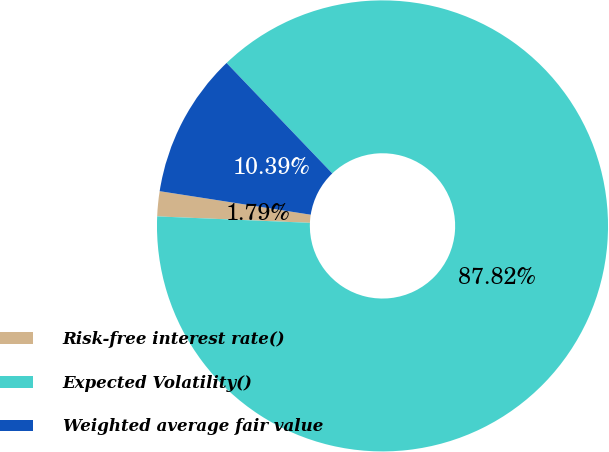Convert chart to OTSL. <chart><loc_0><loc_0><loc_500><loc_500><pie_chart><fcel>Risk-free interest rate()<fcel>Expected Volatility()<fcel>Weighted average fair value<nl><fcel>1.79%<fcel>87.82%<fcel>10.39%<nl></chart> 